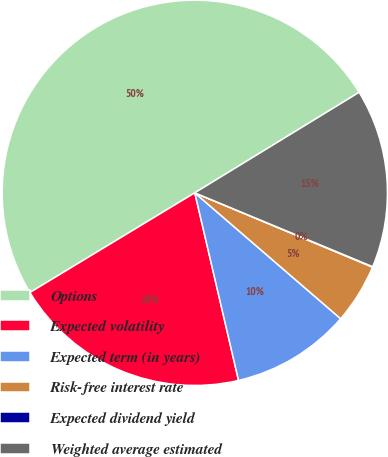Convert chart to OTSL. <chart><loc_0><loc_0><loc_500><loc_500><pie_chart><fcel>Options<fcel>Expected volatility<fcel>Expected term (in years)<fcel>Risk-free interest rate<fcel>Expected dividend yield<fcel>Weighted average estimated<nl><fcel>49.92%<fcel>19.99%<fcel>10.02%<fcel>5.03%<fcel>0.04%<fcel>15.0%<nl></chart> 